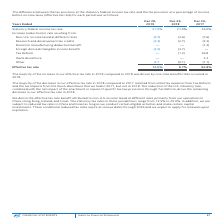From Intel Corporation's financial document, What is the effective tax rate in the year 2017, 2018, and 2019 respectively? The document contains multiple relevant values: 52.8%, 9.7%, 12.5%. From the document: "Effective tax rate 12.5% 9.7% 52.8% Effective tax rate 12.5% 9.7% 52.8% Effective tax rate 12.5% 9.7% 52.8%..." Also, What was the major driver for the increase in effective tax rate in 2019 compared to 2018? One-time benefits that occurred in 2018.. The document states: "ve tax rate in 2019 compared to 2018 was driven by one-time benefits that occurred in 2018...." Also, What does the table show? The difference between the tax provision at the statutory federal income tax rate and the tax provision as a percentage of income before income taxes (effective tax rate) for each period. The document states: "The difference between the tax provision at the statutory federal income tax rate and the tax provision as a percentage of income before income taxes ..." Also, can you calculate: What is the percentage change of the effective tax rate from 2018 to 2019? To answer this question, I need to perform calculations using the financial data. The calculation is: (12.5 - 9.7) / 9.7 , which equals 28.87 (percentage). This is based on the information: "Effective tax rate 12.5% 9.7% 52.8% Effective tax rate 12.5% 9.7% 52.8%..." The key data points involved are: 12.5, 9.7. Also, can you calculate: What is the average effective tax rate from 2017 to 2019? To answer this question, I need to perform calculations using the financial data. The calculation is: (52.8 + 9.7 + 12.5) / 3 , which equals 25 (percentage). This is based on the information: "Effective tax rate 12.5% 9.7% 52.8% Effective tax rate 12.5% 9.7% 52.8% Effective tax rate 12.5% 9.7% 52.8%..." The key data points involved are: 12.5, 52.8, 9.7. Also, can you calculate: What is the change of the tax expenses of Tax Reform from 2017 to 2018? Based on the calculation: (-1.3)-26.8 , the result is -28.1 (percentage). This is based on the information: "Tax Reform — (1.3) 26.8 Tax Reform — (1.3) 26.8..." The key data points involved are: 1.3, 26.8. 